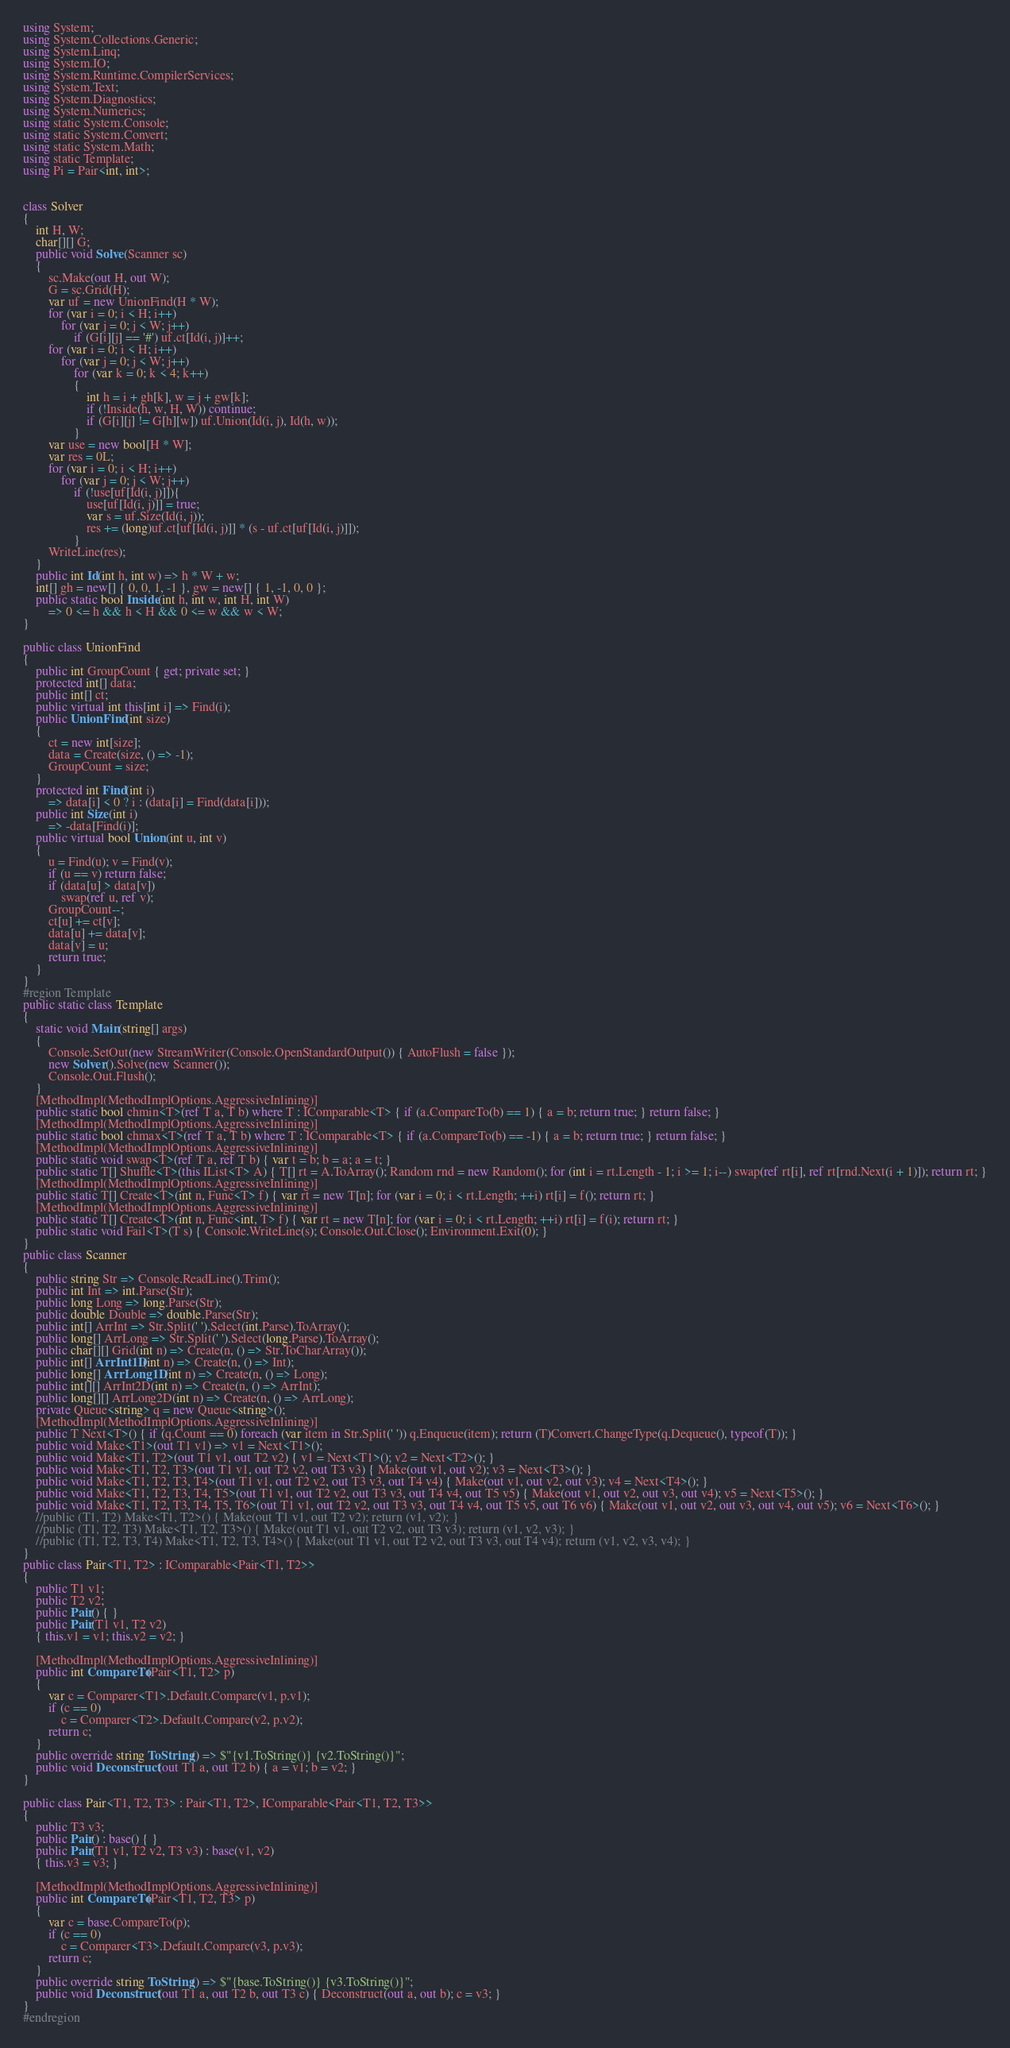<code> <loc_0><loc_0><loc_500><loc_500><_C#_>using System;
using System.Collections.Generic;
using System.Linq;
using System.IO;
using System.Runtime.CompilerServices;
using System.Text;
using System.Diagnostics;
using System.Numerics;
using static System.Console;
using static System.Convert;
using static System.Math;
using static Template;
using Pi = Pair<int, int>;


class Solver
{
    int H, W;
    char[][] G;
    public void Solve(Scanner sc)
    {
        sc.Make(out H, out W);
        G = sc.Grid(H);
        var uf = new UnionFind(H * W);
        for (var i = 0; i < H; i++)
            for (var j = 0; j < W; j++)
                if (G[i][j] == '#') uf.ct[Id(i, j)]++;
        for (var i = 0; i < H; i++)
            for (var j = 0; j < W; j++)
                for (var k = 0; k < 4; k++)
                {
                    int h = i + gh[k], w = j + gw[k];
                    if (!Inside(h, w, H, W)) continue;
                    if (G[i][j] != G[h][w]) uf.Union(Id(i, j), Id(h, w));
                }
        var use = new bool[H * W];
        var res = 0L;
        for (var i = 0; i < H; i++)
            for (var j = 0; j < W; j++)
                if (!use[uf[Id(i, j)]]){
                    use[uf[Id(i, j)]] = true;
                    var s = uf.Size(Id(i, j));
                    res += (long)uf.ct[uf[Id(i, j)]] * (s - uf.ct[uf[Id(i, j)]]);
                }
        WriteLine(res);
    }
    public int Id(int h, int w) => h * W + w;
    int[] gh = new[] { 0, 0, 1, -1 }, gw = new[] { 1, -1, 0, 0 };
    public static bool Inside(int h, int w, int H, int W)
        => 0 <= h && h < H && 0 <= w && w < W;
}

public class UnionFind
{
    public int GroupCount { get; private set; }
    protected int[] data;
    public int[] ct;
    public virtual int this[int i] => Find(i);
    public UnionFind(int size)
    {
        ct = new int[size];
        data = Create(size, () => -1);
        GroupCount = size;
    }
    protected int Find(int i)
        => data[i] < 0 ? i : (data[i] = Find(data[i]));
    public int Size(int i)
        => -data[Find(i)];
    public virtual bool Union(int u, int v)
    {
        u = Find(u); v = Find(v);
        if (u == v) return false;
        if (data[u] > data[v])
            swap(ref u, ref v);
        GroupCount--;
        ct[u] += ct[v];
        data[u] += data[v];
        data[v] = u;
        return true;
    }
}
#region Template
public static class Template
{
    static void Main(string[] args)
    {
        Console.SetOut(new StreamWriter(Console.OpenStandardOutput()) { AutoFlush = false });
        new Solver().Solve(new Scanner());
        Console.Out.Flush();
    }
    [MethodImpl(MethodImplOptions.AggressiveInlining)]
    public static bool chmin<T>(ref T a, T b) where T : IComparable<T> { if (a.CompareTo(b) == 1) { a = b; return true; } return false; }
    [MethodImpl(MethodImplOptions.AggressiveInlining)]
    public static bool chmax<T>(ref T a, T b) where T : IComparable<T> { if (a.CompareTo(b) == -1) { a = b; return true; } return false; }
    [MethodImpl(MethodImplOptions.AggressiveInlining)]
    public static void swap<T>(ref T a, ref T b) { var t = b; b = a; a = t; }
    public static T[] Shuffle<T>(this IList<T> A) { T[] rt = A.ToArray(); Random rnd = new Random(); for (int i = rt.Length - 1; i >= 1; i--) swap(ref rt[i], ref rt[rnd.Next(i + 1)]); return rt; }
    [MethodImpl(MethodImplOptions.AggressiveInlining)]
    public static T[] Create<T>(int n, Func<T> f) { var rt = new T[n]; for (var i = 0; i < rt.Length; ++i) rt[i] = f(); return rt; }
    [MethodImpl(MethodImplOptions.AggressiveInlining)]
    public static T[] Create<T>(int n, Func<int, T> f) { var rt = new T[n]; for (var i = 0; i < rt.Length; ++i) rt[i] = f(i); return rt; }
    public static void Fail<T>(T s) { Console.WriteLine(s); Console.Out.Close(); Environment.Exit(0); }
}
public class Scanner
{
    public string Str => Console.ReadLine().Trim();
    public int Int => int.Parse(Str);
    public long Long => long.Parse(Str);
    public double Double => double.Parse(Str);
    public int[] ArrInt => Str.Split(' ').Select(int.Parse).ToArray();
    public long[] ArrLong => Str.Split(' ').Select(long.Parse).ToArray();
    public char[][] Grid(int n) => Create(n, () => Str.ToCharArray());
    public int[] ArrInt1D(int n) => Create(n, () => Int);
    public long[] ArrLong1D(int n) => Create(n, () => Long);
    public int[][] ArrInt2D(int n) => Create(n, () => ArrInt);
    public long[][] ArrLong2D(int n) => Create(n, () => ArrLong);
    private Queue<string> q = new Queue<string>();
    [MethodImpl(MethodImplOptions.AggressiveInlining)]
    public T Next<T>() { if (q.Count == 0) foreach (var item in Str.Split(' ')) q.Enqueue(item); return (T)Convert.ChangeType(q.Dequeue(), typeof(T)); }
    public void Make<T1>(out T1 v1) => v1 = Next<T1>();
    public void Make<T1, T2>(out T1 v1, out T2 v2) { v1 = Next<T1>(); v2 = Next<T2>(); }
    public void Make<T1, T2, T3>(out T1 v1, out T2 v2, out T3 v3) { Make(out v1, out v2); v3 = Next<T3>(); }
    public void Make<T1, T2, T3, T4>(out T1 v1, out T2 v2, out T3 v3, out T4 v4) { Make(out v1, out v2, out v3); v4 = Next<T4>(); }
    public void Make<T1, T2, T3, T4, T5>(out T1 v1, out T2 v2, out T3 v3, out T4 v4, out T5 v5) { Make(out v1, out v2, out v3, out v4); v5 = Next<T5>(); }
    public void Make<T1, T2, T3, T4, T5, T6>(out T1 v1, out T2 v2, out T3 v3, out T4 v4, out T5 v5, out T6 v6) { Make(out v1, out v2, out v3, out v4, out v5); v6 = Next<T6>(); }
    //public (T1, T2) Make<T1, T2>() { Make(out T1 v1, out T2 v2); return (v1, v2); }
    //public (T1, T2, T3) Make<T1, T2, T3>() { Make(out T1 v1, out T2 v2, out T3 v3); return (v1, v2, v3); }
    //public (T1, T2, T3, T4) Make<T1, T2, T3, T4>() { Make(out T1 v1, out T2 v2, out T3 v3, out T4 v4); return (v1, v2, v3, v4); }
}
public class Pair<T1, T2> : IComparable<Pair<T1, T2>>
{
    public T1 v1;
    public T2 v2;
    public Pair() { }
    public Pair(T1 v1, T2 v2)
    { this.v1 = v1; this.v2 = v2; }

    [MethodImpl(MethodImplOptions.AggressiveInlining)]
    public int CompareTo(Pair<T1, T2> p)
    {
        var c = Comparer<T1>.Default.Compare(v1, p.v1);
        if (c == 0)
            c = Comparer<T2>.Default.Compare(v2, p.v2);
        return c;
    }
    public override string ToString() => $"{v1.ToString()} {v2.ToString()}";
    public void Deconstruct(out T1 a, out T2 b) { a = v1; b = v2; }
}

public class Pair<T1, T2, T3> : Pair<T1, T2>, IComparable<Pair<T1, T2, T3>>
{
    public T3 v3;
    public Pair() : base() { }
    public Pair(T1 v1, T2 v2, T3 v3) : base(v1, v2)
    { this.v3 = v3; }

    [MethodImpl(MethodImplOptions.AggressiveInlining)]
    public int CompareTo(Pair<T1, T2, T3> p)
    {
        var c = base.CompareTo(p);
        if (c == 0)
            c = Comparer<T3>.Default.Compare(v3, p.v3);
        return c;
    }
    public override string ToString() => $"{base.ToString()} {v3.ToString()}";
    public void Deconstruct(out T1 a, out T2 b, out T3 c) { Deconstruct(out a, out b); c = v3; }
}
#endregion</code> 